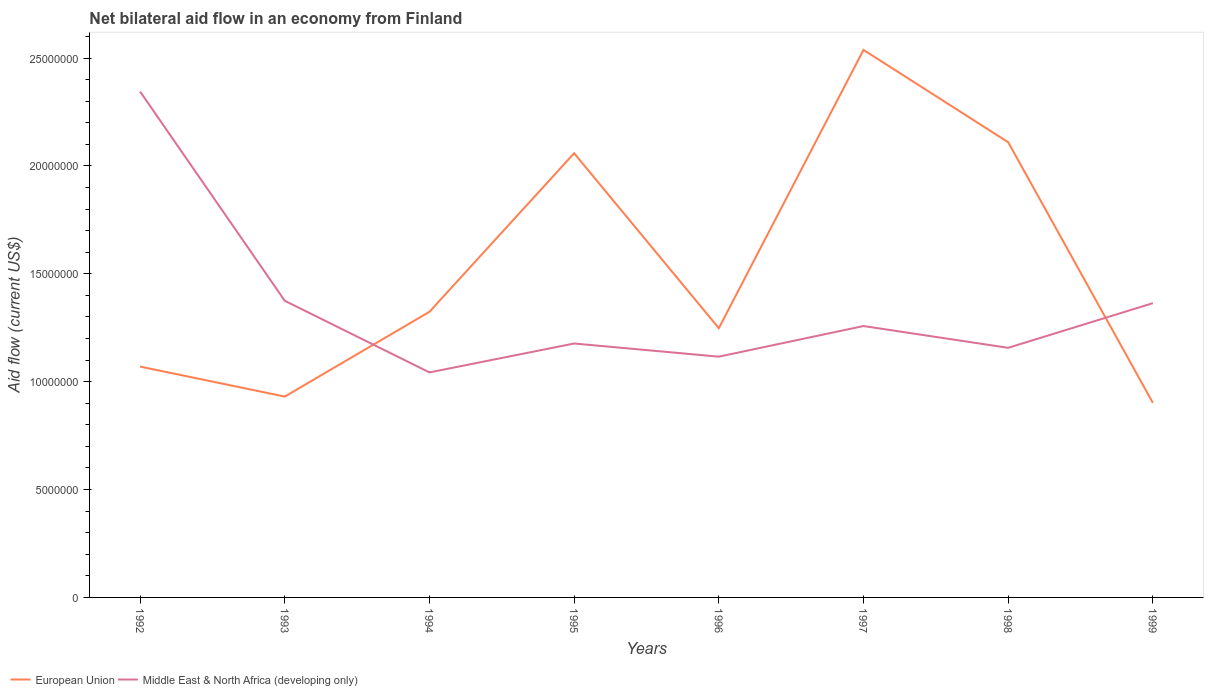How many different coloured lines are there?
Keep it short and to the point. 2. Across all years, what is the maximum net bilateral aid flow in European Union?
Your response must be concise. 9.02e+06. What is the total net bilateral aid flow in European Union in the graph?
Ensure brevity in your answer.  -9.89e+06. What is the difference between the highest and the second highest net bilateral aid flow in Middle East & North Africa (developing only)?
Give a very brief answer. 1.30e+07. Is the net bilateral aid flow in European Union strictly greater than the net bilateral aid flow in Middle East & North Africa (developing only) over the years?
Keep it short and to the point. No. How many years are there in the graph?
Your answer should be very brief. 8. Are the values on the major ticks of Y-axis written in scientific E-notation?
Provide a short and direct response. No. Does the graph contain any zero values?
Offer a very short reply. No. Where does the legend appear in the graph?
Give a very brief answer. Bottom left. How many legend labels are there?
Give a very brief answer. 2. What is the title of the graph?
Offer a very short reply. Net bilateral aid flow in an economy from Finland. What is the Aid flow (current US$) in European Union in 1992?
Make the answer very short. 1.07e+07. What is the Aid flow (current US$) of Middle East & North Africa (developing only) in 1992?
Ensure brevity in your answer.  2.34e+07. What is the Aid flow (current US$) of European Union in 1993?
Your answer should be compact. 9.31e+06. What is the Aid flow (current US$) of Middle East & North Africa (developing only) in 1993?
Give a very brief answer. 1.38e+07. What is the Aid flow (current US$) in European Union in 1994?
Your answer should be very brief. 1.32e+07. What is the Aid flow (current US$) of Middle East & North Africa (developing only) in 1994?
Your answer should be compact. 1.04e+07. What is the Aid flow (current US$) in European Union in 1995?
Ensure brevity in your answer.  2.06e+07. What is the Aid flow (current US$) in Middle East & North Africa (developing only) in 1995?
Ensure brevity in your answer.  1.18e+07. What is the Aid flow (current US$) in European Union in 1996?
Offer a very short reply. 1.25e+07. What is the Aid flow (current US$) in Middle East & North Africa (developing only) in 1996?
Your response must be concise. 1.12e+07. What is the Aid flow (current US$) of European Union in 1997?
Your answer should be compact. 2.54e+07. What is the Aid flow (current US$) of Middle East & North Africa (developing only) in 1997?
Keep it short and to the point. 1.26e+07. What is the Aid flow (current US$) in European Union in 1998?
Offer a very short reply. 2.11e+07. What is the Aid flow (current US$) in Middle East & North Africa (developing only) in 1998?
Provide a short and direct response. 1.16e+07. What is the Aid flow (current US$) of European Union in 1999?
Provide a short and direct response. 9.02e+06. What is the Aid flow (current US$) of Middle East & North Africa (developing only) in 1999?
Offer a terse response. 1.36e+07. Across all years, what is the maximum Aid flow (current US$) of European Union?
Keep it short and to the point. 2.54e+07. Across all years, what is the maximum Aid flow (current US$) of Middle East & North Africa (developing only)?
Your answer should be very brief. 2.34e+07. Across all years, what is the minimum Aid flow (current US$) in European Union?
Offer a very short reply. 9.02e+06. Across all years, what is the minimum Aid flow (current US$) of Middle East & North Africa (developing only)?
Provide a short and direct response. 1.04e+07. What is the total Aid flow (current US$) in European Union in the graph?
Keep it short and to the point. 1.22e+08. What is the total Aid flow (current US$) of Middle East & North Africa (developing only) in the graph?
Keep it short and to the point. 1.08e+08. What is the difference between the Aid flow (current US$) in European Union in 1992 and that in 1993?
Offer a very short reply. 1.39e+06. What is the difference between the Aid flow (current US$) in Middle East & North Africa (developing only) in 1992 and that in 1993?
Ensure brevity in your answer.  9.70e+06. What is the difference between the Aid flow (current US$) of European Union in 1992 and that in 1994?
Provide a succinct answer. -2.54e+06. What is the difference between the Aid flow (current US$) in Middle East & North Africa (developing only) in 1992 and that in 1994?
Your answer should be compact. 1.30e+07. What is the difference between the Aid flow (current US$) of European Union in 1992 and that in 1995?
Keep it short and to the point. -9.89e+06. What is the difference between the Aid flow (current US$) in Middle East & North Africa (developing only) in 1992 and that in 1995?
Give a very brief answer. 1.17e+07. What is the difference between the Aid flow (current US$) of European Union in 1992 and that in 1996?
Offer a very short reply. -1.78e+06. What is the difference between the Aid flow (current US$) in Middle East & North Africa (developing only) in 1992 and that in 1996?
Offer a terse response. 1.23e+07. What is the difference between the Aid flow (current US$) in European Union in 1992 and that in 1997?
Offer a very short reply. -1.47e+07. What is the difference between the Aid flow (current US$) of Middle East & North Africa (developing only) in 1992 and that in 1997?
Provide a succinct answer. 1.09e+07. What is the difference between the Aid flow (current US$) in European Union in 1992 and that in 1998?
Provide a short and direct response. -1.04e+07. What is the difference between the Aid flow (current US$) in Middle East & North Africa (developing only) in 1992 and that in 1998?
Your answer should be compact. 1.19e+07. What is the difference between the Aid flow (current US$) of European Union in 1992 and that in 1999?
Your response must be concise. 1.68e+06. What is the difference between the Aid flow (current US$) of Middle East & North Africa (developing only) in 1992 and that in 1999?
Ensure brevity in your answer.  9.81e+06. What is the difference between the Aid flow (current US$) in European Union in 1993 and that in 1994?
Provide a short and direct response. -3.93e+06. What is the difference between the Aid flow (current US$) in Middle East & North Africa (developing only) in 1993 and that in 1994?
Keep it short and to the point. 3.32e+06. What is the difference between the Aid flow (current US$) of European Union in 1993 and that in 1995?
Offer a very short reply. -1.13e+07. What is the difference between the Aid flow (current US$) of Middle East & North Africa (developing only) in 1993 and that in 1995?
Provide a short and direct response. 1.98e+06. What is the difference between the Aid flow (current US$) of European Union in 1993 and that in 1996?
Provide a succinct answer. -3.17e+06. What is the difference between the Aid flow (current US$) in Middle East & North Africa (developing only) in 1993 and that in 1996?
Your answer should be compact. 2.59e+06. What is the difference between the Aid flow (current US$) of European Union in 1993 and that in 1997?
Your answer should be compact. -1.61e+07. What is the difference between the Aid flow (current US$) in Middle East & North Africa (developing only) in 1993 and that in 1997?
Ensure brevity in your answer.  1.17e+06. What is the difference between the Aid flow (current US$) of European Union in 1993 and that in 1998?
Your answer should be compact. -1.18e+07. What is the difference between the Aid flow (current US$) of Middle East & North Africa (developing only) in 1993 and that in 1998?
Your answer should be very brief. 2.18e+06. What is the difference between the Aid flow (current US$) of European Union in 1993 and that in 1999?
Give a very brief answer. 2.90e+05. What is the difference between the Aid flow (current US$) in Middle East & North Africa (developing only) in 1993 and that in 1999?
Provide a short and direct response. 1.10e+05. What is the difference between the Aid flow (current US$) in European Union in 1994 and that in 1995?
Offer a very short reply. -7.35e+06. What is the difference between the Aid flow (current US$) in Middle East & North Africa (developing only) in 1994 and that in 1995?
Make the answer very short. -1.34e+06. What is the difference between the Aid flow (current US$) in European Union in 1994 and that in 1996?
Make the answer very short. 7.60e+05. What is the difference between the Aid flow (current US$) in Middle East & North Africa (developing only) in 1994 and that in 1996?
Your answer should be very brief. -7.30e+05. What is the difference between the Aid flow (current US$) of European Union in 1994 and that in 1997?
Give a very brief answer. -1.21e+07. What is the difference between the Aid flow (current US$) in Middle East & North Africa (developing only) in 1994 and that in 1997?
Your answer should be very brief. -2.15e+06. What is the difference between the Aid flow (current US$) in European Union in 1994 and that in 1998?
Your answer should be very brief. -7.86e+06. What is the difference between the Aid flow (current US$) in Middle East & North Africa (developing only) in 1994 and that in 1998?
Your answer should be compact. -1.14e+06. What is the difference between the Aid flow (current US$) of European Union in 1994 and that in 1999?
Make the answer very short. 4.22e+06. What is the difference between the Aid flow (current US$) of Middle East & North Africa (developing only) in 1994 and that in 1999?
Ensure brevity in your answer.  -3.21e+06. What is the difference between the Aid flow (current US$) in European Union in 1995 and that in 1996?
Give a very brief answer. 8.11e+06. What is the difference between the Aid flow (current US$) of European Union in 1995 and that in 1997?
Your answer should be compact. -4.79e+06. What is the difference between the Aid flow (current US$) of Middle East & North Africa (developing only) in 1995 and that in 1997?
Ensure brevity in your answer.  -8.10e+05. What is the difference between the Aid flow (current US$) of European Union in 1995 and that in 1998?
Provide a succinct answer. -5.10e+05. What is the difference between the Aid flow (current US$) of European Union in 1995 and that in 1999?
Your response must be concise. 1.16e+07. What is the difference between the Aid flow (current US$) of Middle East & North Africa (developing only) in 1995 and that in 1999?
Make the answer very short. -1.87e+06. What is the difference between the Aid flow (current US$) in European Union in 1996 and that in 1997?
Make the answer very short. -1.29e+07. What is the difference between the Aid flow (current US$) in Middle East & North Africa (developing only) in 1996 and that in 1997?
Make the answer very short. -1.42e+06. What is the difference between the Aid flow (current US$) in European Union in 1996 and that in 1998?
Keep it short and to the point. -8.62e+06. What is the difference between the Aid flow (current US$) in Middle East & North Africa (developing only) in 1996 and that in 1998?
Your response must be concise. -4.10e+05. What is the difference between the Aid flow (current US$) of European Union in 1996 and that in 1999?
Offer a terse response. 3.46e+06. What is the difference between the Aid flow (current US$) in Middle East & North Africa (developing only) in 1996 and that in 1999?
Your response must be concise. -2.48e+06. What is the difference between the Aid flow (current US$) in European Union in 1997 and that in 1998?
Provide a succinct answer. 4.28e+06. What is the difference between the Aid flow (current US$) in Middle East & North Africa (developing only) in 1997 and that in 1998?
Your answer should be very brief. 1.01e+06. What is the difference between the Aid flow (current US$) of European Union in 1997 and that in 1999?
Provide a short and direct response. 1.64e+07. What is the difference between the Aid flow (current US$) in Middle East & North Africa (developing only) in 1997 and that in 1999?
Give a very brief answer. -1.06e+06. What is the difference between the Aid flow (current US$) of European Union in 1998 and that in 1999?
Offer a very short reply. 1.21e+07. What is the difference between the Aid flow (current US$) in Middle East & North Africa (developing only) in 1998 and that in 1999?
Keep it short and to the point. -2.07e+06. What is the difference between the Aid flow (current US$) of European Union in 1992 and the Aid flow (current US$) of Middle East & North Africa (developing only) in 1993?
Offer a terse response. -3.05e+06. What is the difference between the Aid flow (current US$) of European Union in 1992 and the Aid flow (current US$) of Middle East & North Africa (developing only) in 1995?
Provide a succinct answer. -1.07e+06. What is the difference between the Aid flow (current US$) in European Union in 1992 and the Aid flow (current US$) in Middle East & North Africa (developing only) in 1996?
Your answer should be very brief. -4.60e+05. What is the difference between the Aid flow (current US$) in European Union in 1992 and the Aid flow (current US$) in Middle East & North Africa (developing only) in 1997?
Keep it short and to the point. -1.88e+06. What is the difference between the Aid flow (current US$) of European Union in 1992 and the Aid flow (current US$) of Middle East & North Africa (developing only) in 1998?
Give a very brief answer. -8.70e+05. What is the difference between the Aid flow (current US$) of European Union in 1992 and the Aid flow (current US$) of Middle East & North Africa (developing only) in 1999?
Provide a short and direct response. -2.94e+06. What is the difference between the Aid flow (current US$) in European Union in 1993 and the Aid flow (current US$) in Middle East & North Africa (developing only) in 1994?
Your answer should be very brief. -1.12e+06. What is the difference between the Aid flow (current US$) of European Union in 1993 and the Aid flow (current US$) of Middle East & North Africa (developing only) in 1995?
Provide a succinct answer. -2.46e+06. What is the difference between the Aid flow (current US$) of European Union in 1993 and the Aid flow (current US$) of Middle East & North Africa (developing only) in 1996?
Give a very brief answer. -1.85e+06. What is the difference between the Aid flow (current US$) of European Union in 1993 and the Aid flow (current US$) of Middle East & North Africa (developing only) in 1997?
Keep it short and to the point. -3.27e+06. What is the difference between the Aid flow (current US$) of European Union in 1993 and the Aid flow (current US$) of Middle East & North Africa (developing only) in 1998?
Make the answer very short. -2.26e+06. What is the difference between the Aid flow (current US$) of European Union in 1993 and the Aid flow (current US$) of Middle East & North Africa (developing only) in 1999?
Ensure brevity in your answer.  -4.33e+06. What is the difference between the Aid flow (current US$) of European Union in 1994 and the Aid flow (current US$) of Middle East & North Africa (developing only) in 1995?
Offer a terse response. 1.47e+06. What is the difference between the Aid flow (current US$) in European Union in 1994 and the Aid flow (current US$) in Middle East & North Africa (developing only) in 1996?
Give a very brief answer. 2.08e+06. What is the difference between the Aid flow (current US$) in European Union in 1994 and the Aid flow (current US$) in Middle East & North Africa (developing only) in 1998?
Ensure brevity in your answer.  1.67e+06. What is the difference between the Aid flow (current US$) of European Union in 1994 and the Aid flow (current US$) of Middle East & North Africa (developing only) in 1999?
Ensure brevity in your answer.  -4.00e+05. What is the difference between the Aid flow (current US$) of European Union in 1995 and the Aid flow (current US$) of Middle East & North Africa (developing only) in 1996?
Offer a terse response. 9.43e+06. What is the difference between the Aid flow (current US$) in European Union in 1995 and the Aid flow (current US$) in Middle East & North Africa (developing only) in 1997?
Make the answer very short. 8.01e+06. What is the difference between the Aid flow (current US$) in European Union in 1995 and the Aid flow (current US$) in Middle East & North Africa (developing only) in 1998?
Give a very brief answer. 9.02e+06. What is the difference between the Aid flow (current US$) in European Union in 1995 and the Aid flow (current US$) in Middle East & North Africa (developing only) in 1999?
Your answer should be very brief. 6.95e+06. What is the difference between the Aid flow (current US$) in European Union in 1996 and the Aid flow (current US$) in Middle East & North Africa (developing only) in 1997?
Ensure brevity in your answer.  -1.00e+05. What is the difference between the Aid flow (current US$) in European Union in 1996 and the Aid flow (current US$) in Middle East & North Africa (developing only) in 1998?
Ensure brevity in your answer.  9.10e+05. What is the difference between the Aid flow (current US$) in European Union in 1996 and the Aid flow (current US$) in Middle East & North Africa (developing only) in 1999?
Keep it short and to the point. -1.16e+06. What is the difference between the Aid flow (current US$) in European Union in 1997 and the Aid flow (current US$) in Middle East & North Africa (developing only) in 1998?
Provide a short and direct response. 1.38e+07. What is the difference between the Aid flow (current US$) in European Union in 1997 and the Aid flow (current US$) in Middle East & North Africa (developing only) in 1999?
Your answer should be compact. 1.17e+07. What is the difference between the Aid flow (current US$) in European Union in 1998 and the Aid flow (current US$) in Middle East & North Africa (developing only) in 1999?
Ensure brevity in your answer.  7.46e+06. What is the average Aid flow (current US$) in European Union per year?
Ensure brevity in your answer.  1.52e+07. What is the average Aid flow (current US$) of Middle East & North Africa (developing only) per year?
Ensure brevity in your answer.  1.35e+07. In the year 1992, what is the difference between the Aid flow (current US$) in European Union and Aid flow (current US$) in Middle East & North Africa (developing only)?
Give a very brief answer. -1.28e+07. In the year 1993, what is the difference between the Aid flow (current US$) of European Union and Aid flow (current US$) of Middle East & North Africa (developing only)?
Your answer should be very brief. -4.44e+06. In the year 1994, what is the difference between the Aid flow (current US$) in European Union and Aid flow (current US$) in Middle East & North Africa (developing only)?
Give a very brief answer. 2.81e+06. In the year 1995, what is the difference between the Aid flow (current US$) of European Union and Aid flow (current US$) of Middle East & North Africa (developing only)?
Your response must be concise. 8.82e+06. In the year 1996, what is the difference between the Aid flow (current US$) of European Union and Aid flow (current US$) of Middle East & North Africa (developing only)?
Ensure brevity in your answer.  1.32e+06. In the year 1997, what is the difference between the Aid flow (current US$) in European Union and Aid flow (current US$) in Middle East & North Africa (developing only)?
Offer a terse response. 1.28e+07. In the year 1998, what is the difference between the Aid flow (current US$) in European Union and Aid flow (current US$) in Middle East & North Africa (developing only)?
Offer a very short reply. 9.53e+06. In the year 1999, what is the difference between the Aid flow (current US$) in European Union and Aid flow (current US$) in Middle East & North Africa (developing only)?
Your response must be concise. -4.62e+06. What is the ratio of the Aid flow (current US$) of European Union in 1992 to that in 1993?
Keep it short and to the point. 1.15. What is the ratio of the Aid flow (current US$) of Middle East & North Africa (developing only) in 1992 to that in 1993?
Your response must be concise. 1.71. What is the ratio of the Aid flow (current US$) of European Union in 1992 to that in 1994?
Your answer should be very brief. 0.81. What is the ratio of the Aid flow (current US$) in Middle East & North Africa (developing only) in 1992 to that in 1994?
Keep it short and to the point. 2.25. What is the ratio of the Aid flow (current US$) of European Union in 1992 to that in 1995?
Make the answer very short. 0.52. What is the ratio of the Aid flow (current US$) in Middle East & North Africa (developing only) in 1992 to that in 1995?
Your answer should be very brief. 1.99. What is the ratio of the Aid flow (current US$) in European Union in 1992 to that in 1996?
Keep it short and to the point. 0.86. What is the ratio of the Aid flow (current US$) of Middle East & North Africa (developing only) in 1992 to that in 1996?
Offer a very short reply. 2.1. What is the ratio of the Aid flow (current US$) in European Union in 1992 to that in 1997?
Keep it short and to the point. 0.42. What is the ratio of the Aid flow (current US$) of Middle East & North Africa (developing only) in 1992 to that in 1997?
Give a very brief answer. 1.86. What is the ratio of the Aid flow (current US$) of European Union in 1992 to that in 1998?
Give a very brief answer. 0.51. What is the ratio of the Aid flow (current US$) in Middle East & North Africa (developing only) in 1992 to that in 1998?
Your answer should be compact. 2.03. What is the ratio of the Aid flow (current US$) of European Union in 1992 to that in 1999?
Offer a terse response. 1.19. What is the ratio of the Aid flow (current US$) in Middle East & North Africa (developing only) in 1992 to that in 1999?
Make the answer very short. 1.72. What is the ratio of the Aid flow (current US$) in European Union in 1993 to that in 1994?
Ensure brevity in your answer.  0.7. What is the ratio of the Aid flow (current US$) of Middle East & North Africa (developing only) in 1993 to that in 1994?
Offer a very short reply. 1.32. What is the ratio of the Aid flow (current US$) in European Union in 1993 to that in 1995?
Provide a short and direct response. 0.45. What is the ratio of the Aid flow (current US$) of Middle East & North Africa (developing only) in 1993 to that in 1995?
Your response must be concise. 1.17. What is the ratio of the Aid flow (current US$) in European Union in 1993 to that in 1996?
Keep it short and to the point. 0.75. What is the ratio of the Aid flow (current US$) in Middle East & North Africa (developing only) in 1993 to that in 1996?
Your response must be concise. 1.23. What is the ratio of the Aid flow (current US$) in European Union in 1993 to that in 1997?
Ensure brevity in your answer.  0.37. What is the ratio of the Aid flow (current US$) in Middle East & North Africa (developing only) in 1993 to that in 1997?
Your answer should be compact. 1.09. What is the ratio of the Aid flow (current US$) in European Union in 1993 to that in 1998?
Your answer should be compact. 0.44. What is the ratio of the Aid flow (current US$) of Middle East & North Africa (developing only) in 1993 to that in 1998?
Your response must be concise. 1.19. What is the ratio of the Aid flow (current US$) in European Union in 1993 to that in 1999?
Give a very brief answer. 1.03. What is the ratio of the Aid flow (current US$) of Middle East & North Africa (developing only) in 1993 to that in 1999?
Make the answer very short. 1.01. What is the ratio of the Aid flow (current US$) in European Union in 1994 to that in 1995?
Your answer should be very brief. 0.64. What is the ratio of the Aid flow (current US$) of Middle East & North Africa (developing only) in 1994 to that in 1995?
Provide a succinct answer. 0.89. What is the ratio of the Aid flow (current US$) of European Union in 1994 to that in 1996?
Keep it short and to the point. 1.06. What is the ratio of the Aid flow (current US$) of Middle East & North Africa (developing only) in 1994 to that in 1996?
Ensure brevity in your answer.  0.93. What is the ratio of the Aid flow (current US$) in European Union in 1994 to that in 1997?
Provide a succinct answer. 0.52. What is the ratio of the Aid flow (current US$) of Middle East & North Africa (developing only) in 1994 to that in 1997?
Your answer should be compact. 0.83. What is the ratio of the Aid flow (current US$) of European Union in 1994 to that in 1998?
Make the answer very short. 0.63. What is the ratio of the Aid flow (current US$) of Middle East & North Africa (developing only) in 1994 to that in 1998?
Give a very brief answer. 0.9. What is the ratio of the Aid flow (current US$) in European Union in 1994 to that in 1999?
Offer a terse response. 1.47. What is the ratio of the Aid flow (current US$) in Middle East & North Africa (developing only) in 1994 to that in 1999?
Offer a terse response. 0.76. What is the ratio of the Aid flow (current US$) in European Union in 1995 to that in 1996?
Your answer should be very brief. 1.65. What is the ratio of the Aid flow (current US$) in Middle East & North Africa (developing only) in 1995 to that in 1996?
Offer a very short reply. 1.05. What is the ratio of the Aid flow (current US$) of European Union in 1995 to that in 1997?
Offer a terse response. 0.81. What is the ratio of the Aid flow (current US$) of Middle East & North Africa (developing only) in 1995 to that in 1997?
Keep it short and to the point. 0.94. What is the ratio of the Aid flow (current US$) of European Union in 1995 to that in 1998?
Make the answer very short. 0.98. What is the ratio of the Aid flow (current US$) in Middle East & North Africa (developing only) in 1995 to that in 1998?
Provide a short and direct response. 1.02. What is the ratio of the Aid flow (current US$) in European Union in 1995 to that in 1999?
Offer a very short reply. 2.28. What is the ratio of the Aid flow (current US$) in Middle East & North Africa (developing only) in 1995 to that in 1999?
Offer a very short reply. 0.86. What is the ratio of the Aid flow (current US$) in European Union in 1996 to that in 1997?
Offer a terse response. 0.49. What is the ratio of the Aid flow (current US$) of Middle East & North Africa (developing only) in 1996 to that in 1997?
Make the answer very short. 0.89. What is the ratio of the Aid flow (current US$) in European Union in 1996 to that in 1998?
Ensure brevity in your answer.  0.59. What is the ratio of the Aid flow (current US$) of Middle East & North Africa (developing only) in 1996 to that in 1998?
Give a very brief answer. 0.96. What is the ratio of the Aid flow (current US$) in European Union in 1996 to that in 1999?
Offer a very short reply. 1.38. What is the ratio of the Aid flow (current US$) in Middle East & North Africa (developing only) in 1996 to that in 1999?
Make the answer very short. 0.82. What is the ratio of the Aid flow (current US$) in European Union in 1997 to that in 1998?
Give a very brief answer. 1.2. What is the ratio of the Aid flow (current US$) in Middle East & North Africa (developing only) in 1997 to that in 1998?
Offer a very short reply. 1.09. What is the ratio of the Aid flow (current US$) of European Union in 1997 to that in 1999?
Ensure brevity in your answer.  2.81. What is the ratio of the Aid flow (current US$) in Middle East & North Africa (developing only) in 1997 to that in 1999?
Provide a succinct answer. 0.92. What is the ratio of the Aid flow (current US$) in European Union in 1998 to that in 1999?
Keep it short and to the point. 2.34. What is the ratio of the Aid flow (current US$) in Middle East & North Africa (developing only) in 1998 to that in 1999?
Your response must be concise. 0.85. What is the difference between the highest and the second highest Aid flow (current US$) of European Union?
Your answer should be very brief. 4.28e+06. What is the difference between the highest and the second highest Aid flow (current US$) of Middle East & North Africa (developing only)?
Your answer should be very brief. 9.70e+06. What is the difference between the highest and the lowest Aid flow (current US$) in European Union?
Provide a succinct answer. 1.64e+07. What is the difference between the highest and the lowest Aid flow (current US$) in Middle East & North Africa (developing only)?
Keep it short and to the point. 1.30e+07. 